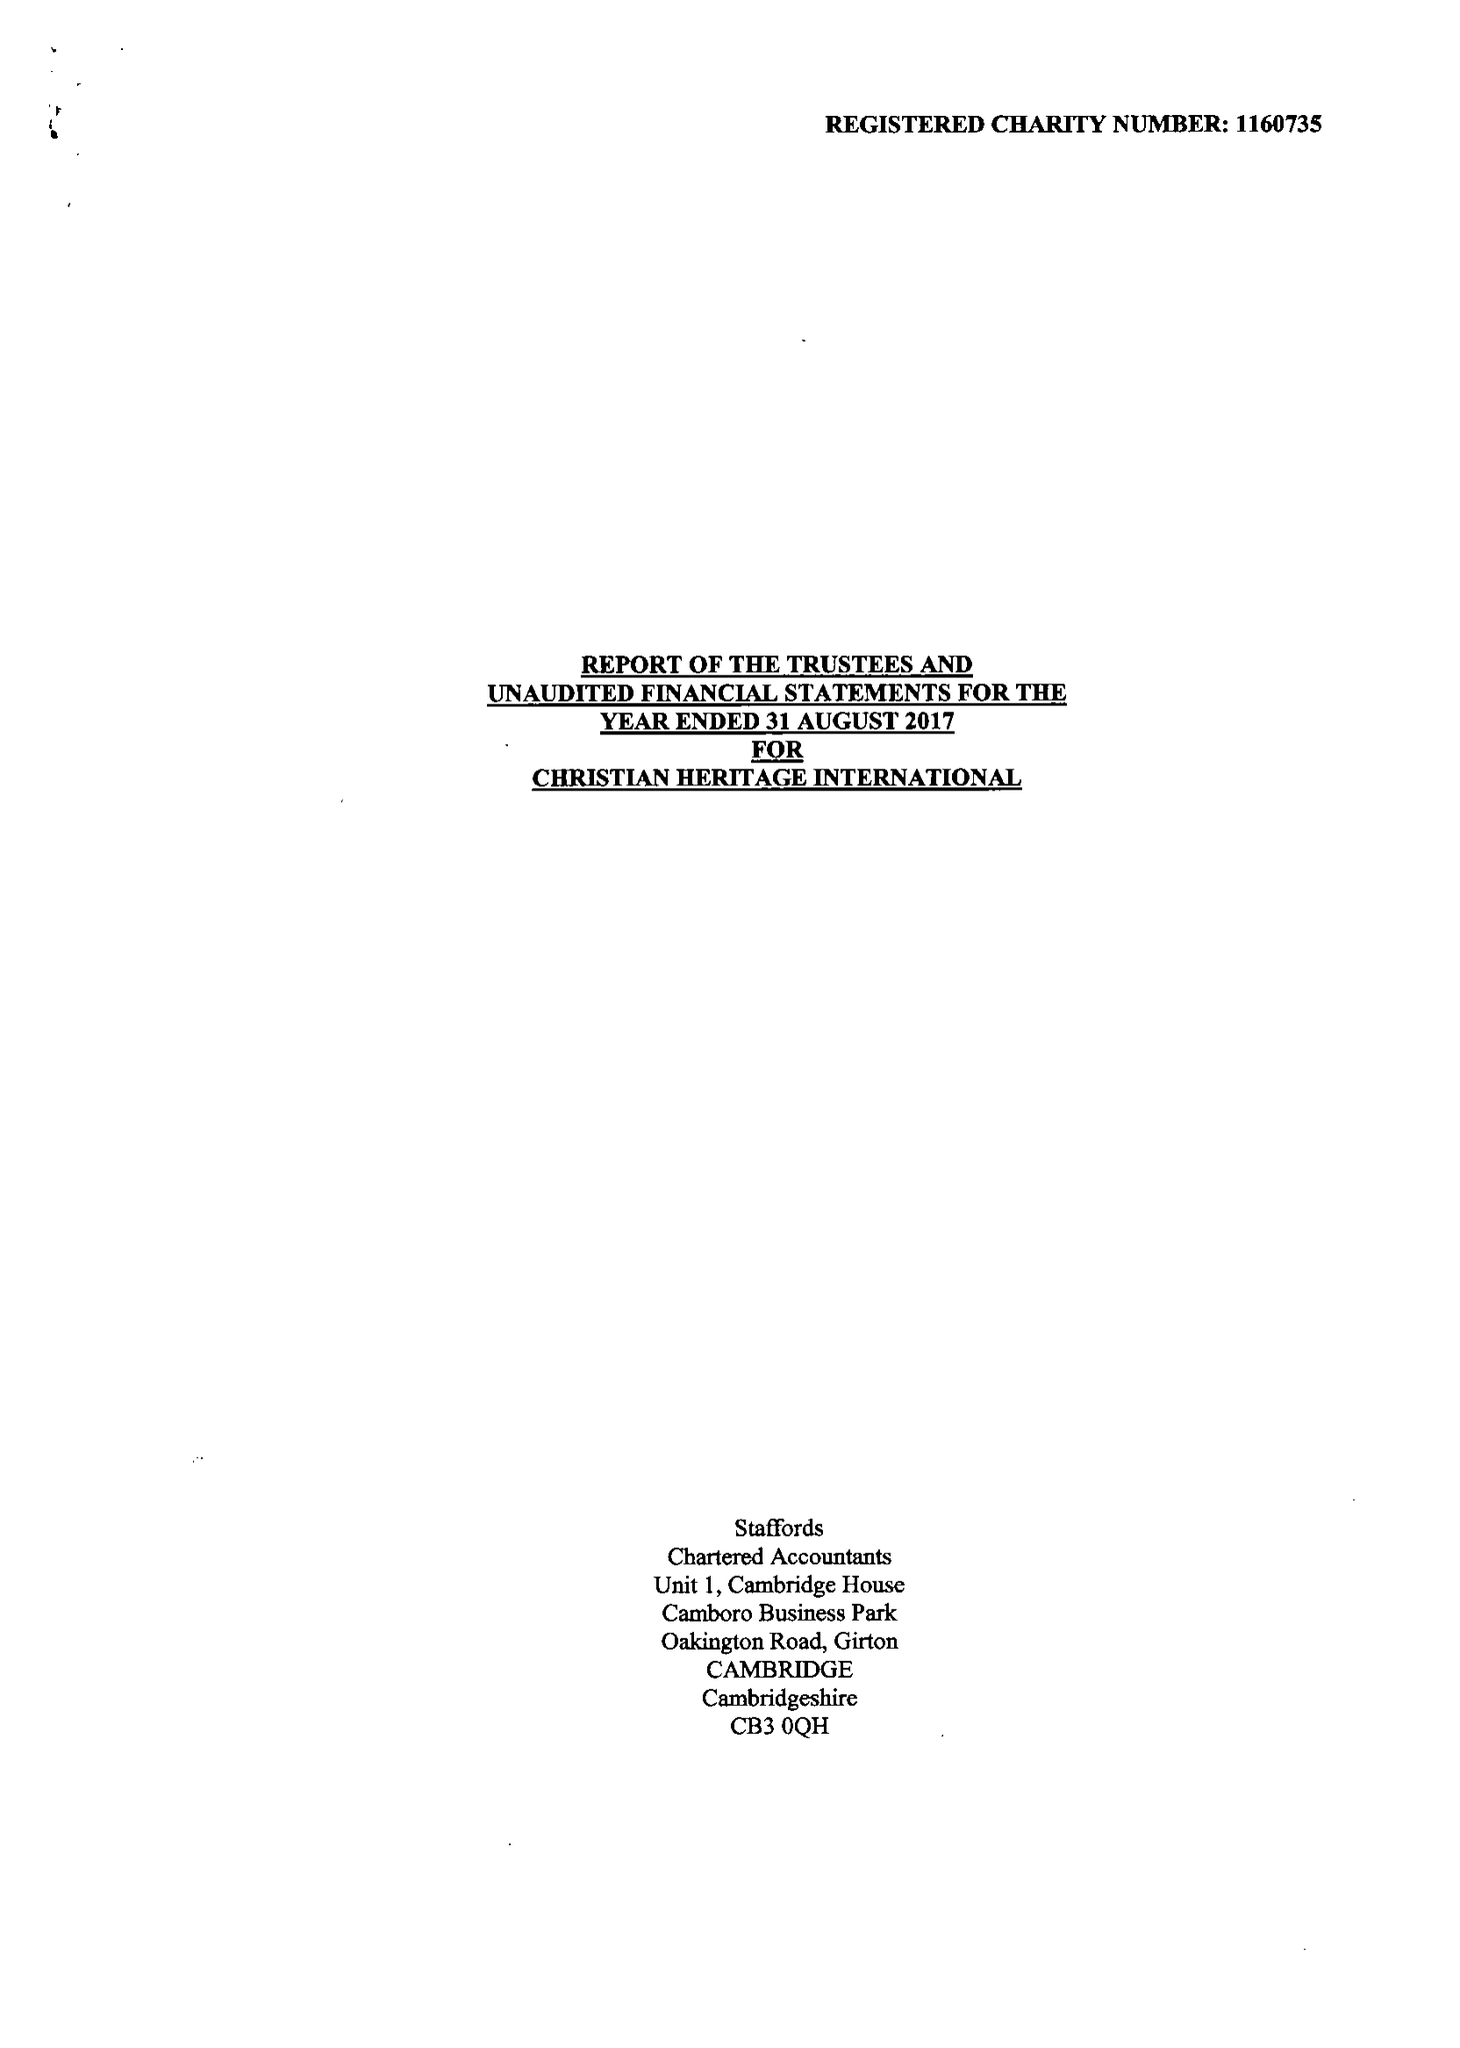What is the value for the address__post_town?
Answer the question using a single word or phrase. NORTHWOOD 